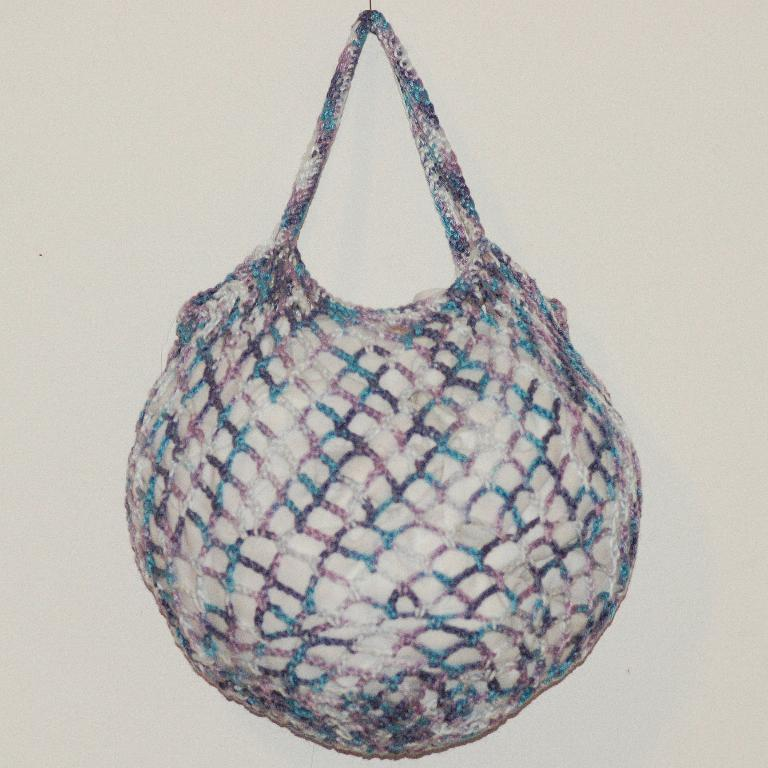What object is hanging on the wall in the image? There is a bag hanging on the wall in the image. What type of toothpaste is being used by the crow in the image? There is no toothpaste or crow present in the image. 